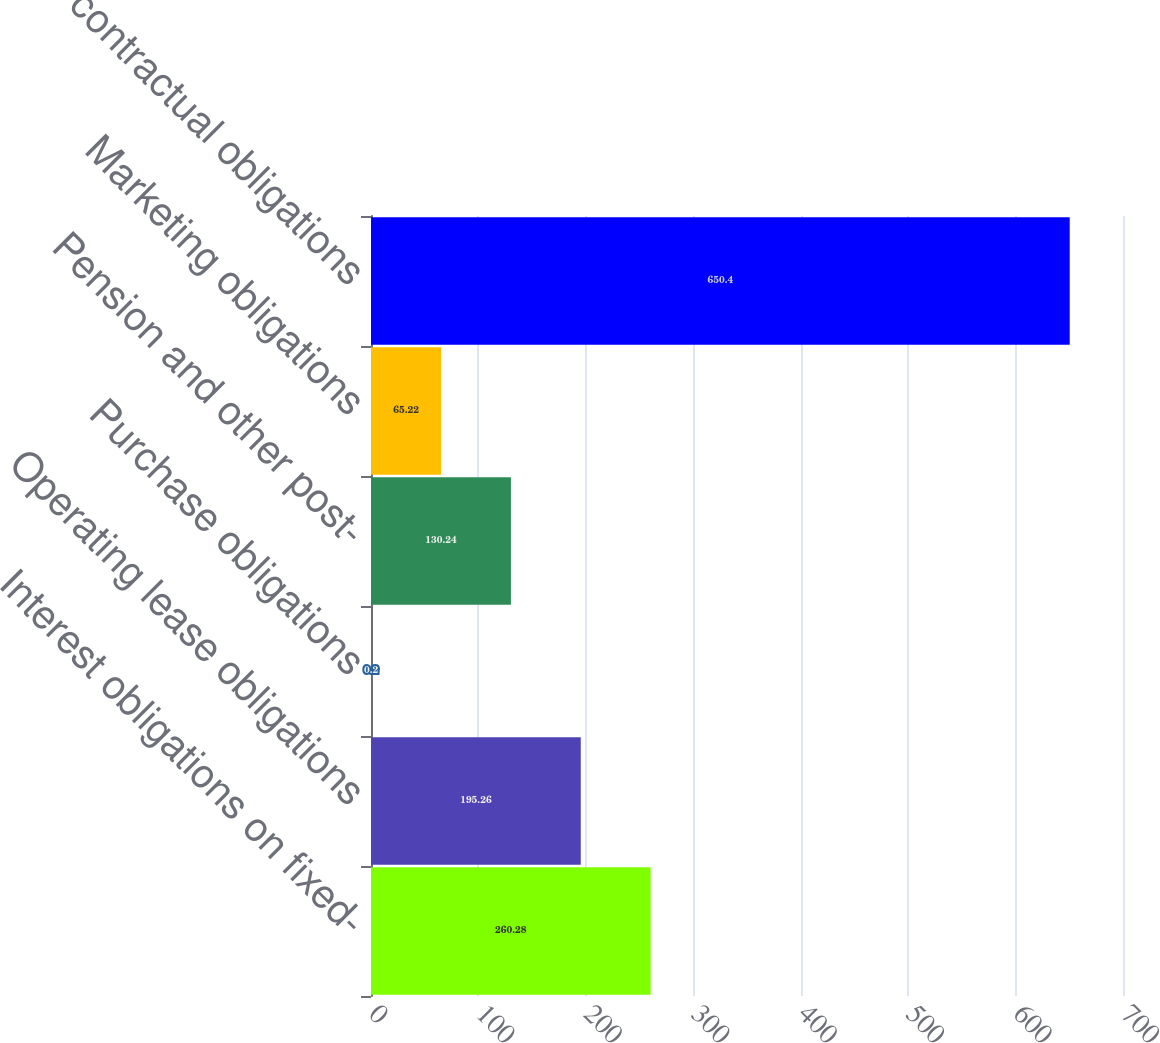Convert chart. <chart><loc_0><loc_0><loc_500><loc_500><bar_chart><fcel>Interest obligations on fixed-<fcel>Operating lease obligations<fcel>Purchase obligations<fcel>Pension and other post-<fcel>Marketing obligations<fcel>Total contractual obligations<nl><fcel>260.28<fcel>195.26<fcel>0.2<fcel>130.24<fcel>65.22<fcel>650.4<nl></chart> 